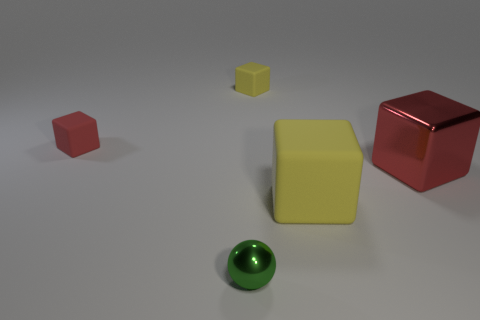Subtract 1 blocks. How many blocks are left? 3 Add 4 tiny yellow cylinders. How many objects exist? 9 Subtract all blocks. How many objects are left? 1 Add 5 red cubes. How many red cubes are left? 7 Add 5 big blue rubber objects. How many big blue rubber objects exist? 5 Subtract 2 red cubes. How many objects are left? 3 Subtract all small matte cubes. Subtract all tiny rubber objects. How many objects are left? 1 